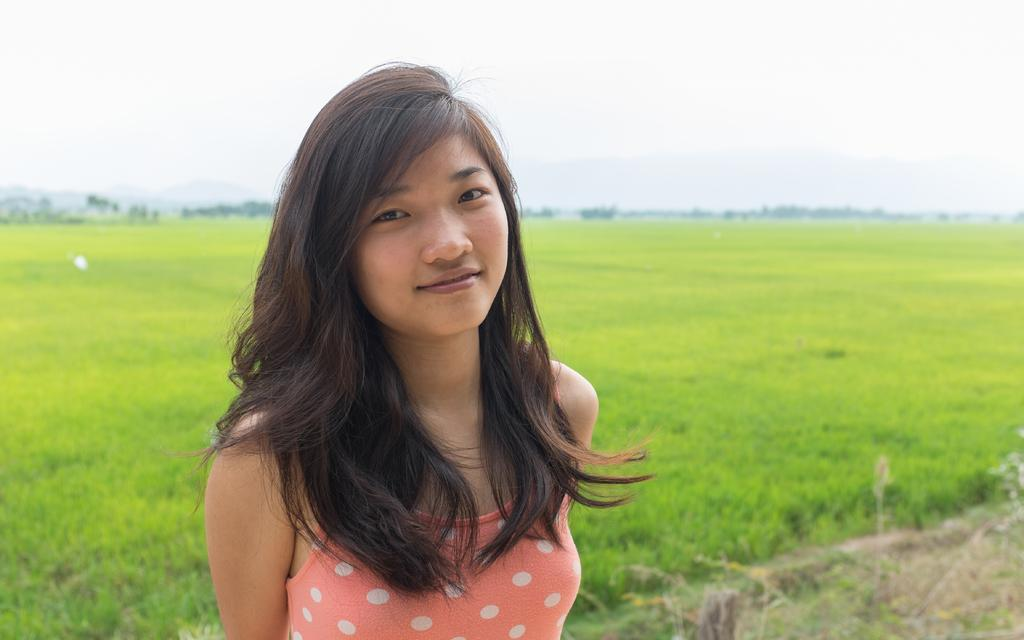Who is the main subject in the image? There is a woman in the image. What is the woman doing in the image? The woman is smiling and posing for the picture. What can be seen in the background of the image? There is a field and many trees in the background of the image. What is visible at the top of the image? The sky is visible at the top of the image. What type of plate is being used to serve the food in the image? There is no plate or food present in the image; it features a woman posing for a picture in a field with trees in the background. How does the coastline look in the image? There is no coastline present in the image; it features a woman posing for a picture in a field with trees in the background. 